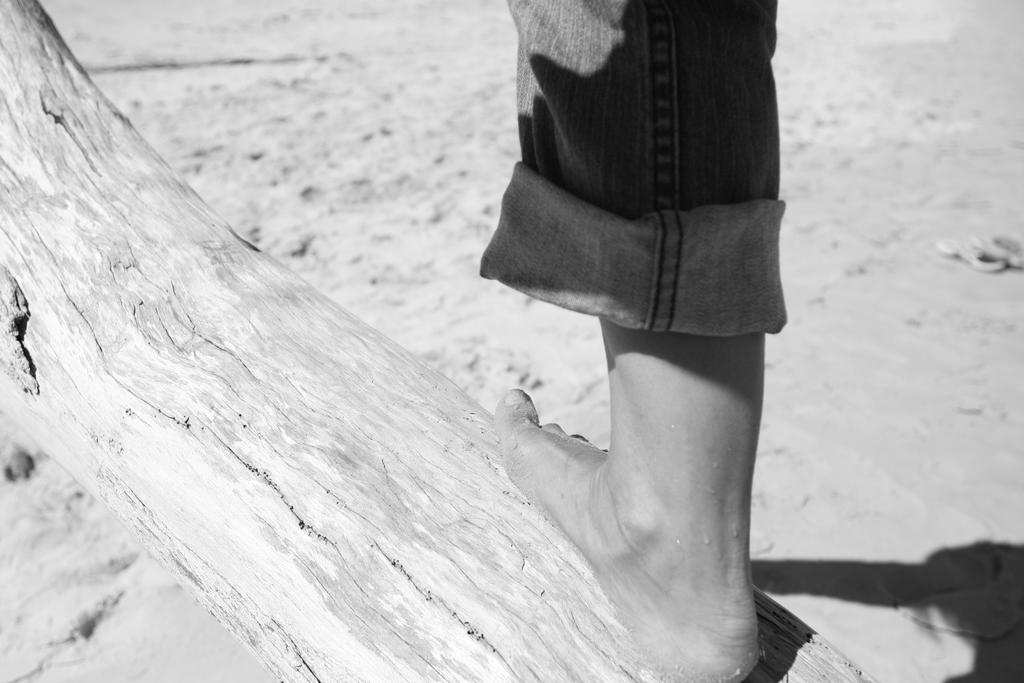What is located at the bottom of the image? There is a log at the bottom of the image. What is in contact with the log? A person's leg is on the log. What type of terrain can be seen in the background of the image? There is sand visible in the background of the image. What color is the person's hair in the image? There is no information about the person's hair in the image, as only their leg is visible. Is there a kite flying in the image? There is no mention of a kite in the image, so it cannot be determined if one is present. 